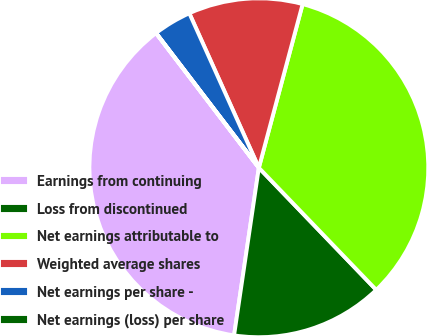Convert chart. <chart><loc_0><loc_0><loc_500><loc_500><pie_chart><fcel>Earnings from continuing<fcel>Loss from discontinued<fcel>Net earnings attributable to<fcel>Weighted average shares<fcel>Net earnings per share -<fcel>Net earnings (loss) per share<nl><fcel>37.28%<fcel>14.52%<fcel>33.65%<fcel>10.89%<fcel>3.64%<fcel>0.01%<nl></chart> 